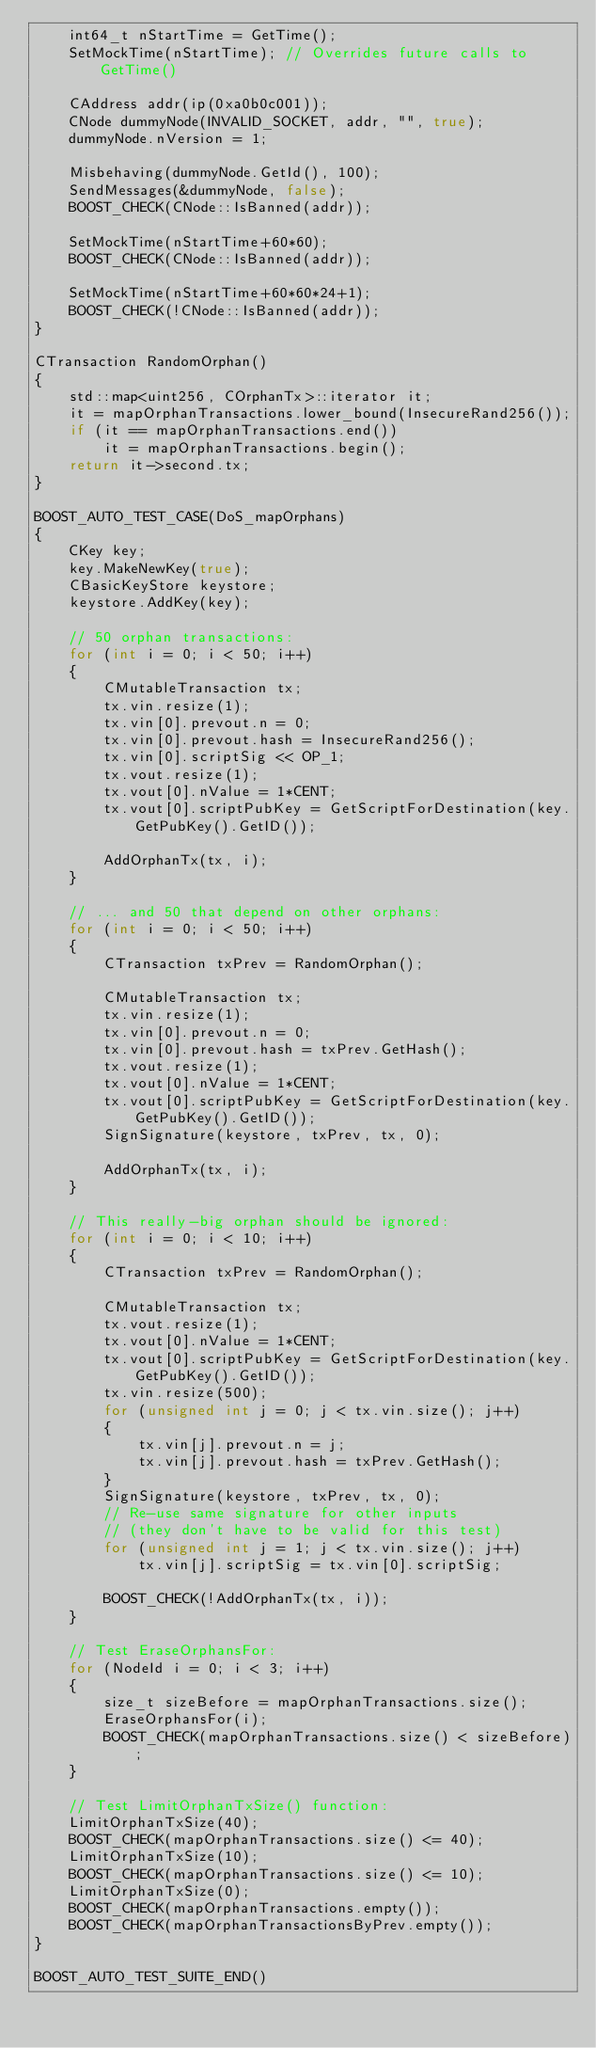<code> <loc_0><loc_0><loc_500><loc_500><_C++_>    int64_t nStartTime = GetTime();
    SetMockTime(nStartTime); // Overrides future calls to GetTime()

    CAddress addr(ip(0xa0b0c001));
    CNode dummyNode(INVALID_SOCKET, addr, "", true);
    dummyNode.nVersion = 1;

    Misbehaving(dummyNode.GetId(), 100);
    SendMessages(&dummyNode, false);
    BOOST_CHECK(CNode::IsBanned(addr));

    SetMockTime(nStartTime+60*60);
    BOOST_CHECK(CNode::IsBanned(addr));

    SetMockTime(nStartTime+60*60*24+1);
    BOOST_CHECK(!CNode::IsBanned(addr));
}

CTransaction RandomOrphan()
{
    std::map<uint256, COrphanTx>::iterator it;
    it = mapOrphanTransactions.lower_bound(InsecureRand256());
    if (it == mapOrphanTransactions.end())
        it = mapOrphanTransactions.begin();
    return it->second.tx;
}

BOOST_AUTO_TEST_CASE(DoS_mapOrphans)
{
    CKey key;
    key.MakeNewKey(true);
    CBasicKeyStore keystore;
    keystore.AddKey(key);

    // 50 orphan transactions:
    for (int i = 0; i < 50; i++)
    {
        CMutableTransaction tx;
        tx.vin.resize(1);
        tx.vin[0].prevout.n = 0;
        tx.vin[0].prevout.hash = InsecureRand256();
        tx.vin[0].scriptSig << OP_1;
        tx.vout.resize(1);
        tx.vout[0].nValue = 1*CENT;
        tx.vout[0].scriptPubKey = GetScriptForDestination(key.GetPubKey().GetID());

        AddOrphanTx(tx, i);
    }

    // ... and 50 that depend on other orphans:
    for (int i = 0; i < 50; i++)
    {
        CTransaction txPrev = RandomOrphan();

        CMutableTransaction tx;
        tx.vin.resize(1);
        tx.vin[0].prevout.n = 0;
        tx.vin[0].prevout.hash = txPrev.GetHash();
        tx.vout.resize(1);
        tx.vout[0].nValue = 1*CENT;
        tx.vout[0].scriptPubKey = GetScriptForDestination(key.GetPubKey().GetID());
        SignSignature(keystore, txPrev, tx, 0);

        AddOrphanTx(tx, i);
    }

    // This really-big orphan should be ignored:
    for (int i = 0; i < 10; i++)
    {
        CTransaction txPrev = RandomOrphan();

        CMutableTransaction tx;
        tx.vout.resize(1);
        tx.vout[0].nValue = 1*CENT;
        tx.vout[0].scriptPubKey = GetScriptForDestination(key.GetPubKey().GetID());
        tx.vin.resize(500);
        for (unsigned int j = 0; j < tx.vin.size(); j++)
        {
            tx.vin[j].prevout.n = j;
            tx.vin[j].prevout.hash = txPrev.GetHash();
        }
        SignSignature(keystore, txPrev, tx, 0);
        // Re-use same signature for other inputs
        // (they don't have to be valid for this test)
        for (unsigned int j = 1; j < tx.vin.size(); j++)
            tx.vin[j].scriptSig = tx.vin[0].scriptSig;

        BOOST_CHECK(!AddOrphanTx(tx, i));
    }

    // Test EraseOrphansFor:
    for (NodeId i = 0; i < 3; i++)
    {
        size_t sizeBefore = mapOrphanTransactions.size();
        EraseOrphansFor(i);
        BOOST_CHECK(mapOrphanTransactions.size() < sizeBefore);
    }

    // Test LimitOrphanTxSize() function:
    LimitOrphanTxSize(40);
    BOOST_CHECK(mapOrphanTransactions.size() <= 40);
    LimitOrphanTxSize(10);
    BOOST_CHECK(mapOrphanTransactions.size() <= 10);
    LimitOrphanTxSize(0);
    BOOST_CHECK(mapOrphanTransactions.empty());
    BOOST_CHECK(mapOrphanTransactionsByPrev.empty());
}

BOOST_AUTO_TEST_SUITE_END()
</code> 